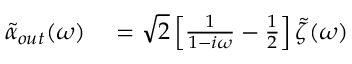<formula> <loc_0><loc_0><loc_500><loc_500>\begin{array} { r l } { \tilde { \alpha } _ { o u t } ( \omega ) } & = \sqrt { 2 } \left [ \frac { 1 } { 1 - i \omega } - \frac { 1 } { 2 } \right ] \tilde { \zeta } ( \omega ) } \end{array}</formula> 